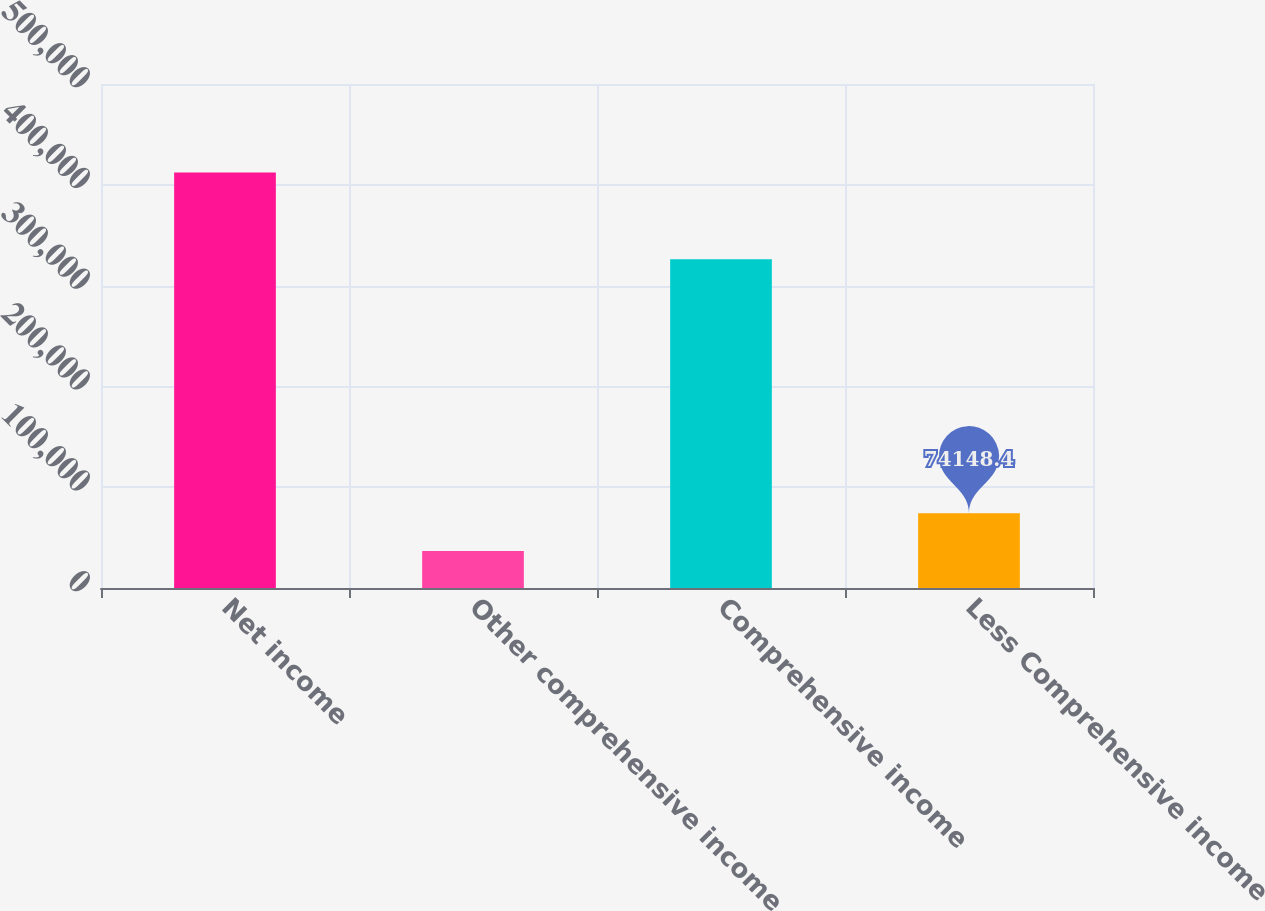Convert chart. <chart><loc_0><loc_0><loc_500><loc_500><bar_chart><fcel>Net income<fcel>Other comprehensive income<fcel>Comprehensive income<fcel>Less Comprehensive income<nl><fcel>412251<fcel>36671<fcel>326073<fcel>74148.4<nl></chart> 